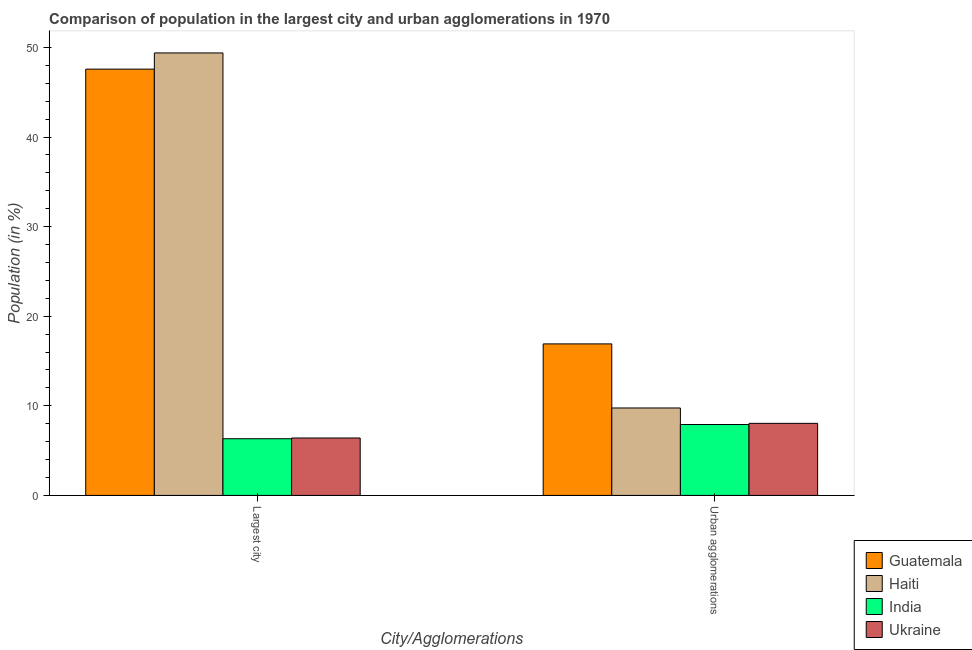Are the number of bars per tick equal to the number of legend labels?
Offer a terse response. Yes. Are the number of bars on each tick of the X-axis equal?
Your answer should be compact. Yes. What is the label of the 1st group of bars from the left?
Ensure brevity in your answer.  Largest city. What is the population in the largest city in Guatemala?
Make the answer very short. 47.58. Across all countries, what is the maximum population in the largest city?
Offer a terse response. 49.38. Across all countries, what is the minimum population in the largest city?
Offer a very short reply. 6.33. In which country was the population in urban agglomerations maximum?
Keep it short and to the point. Guatemala. In which country was the population in urban agglomerations minimum?
Your answer should be compact. India. What is the total population in urban agglomerations in the graph?
Offer a very short reply. 42.63. What is the difference between the population in the largest city in India and that in Haiti?
Your response must be concise. -43.06. What is the difference between the population in urban agglomerations in Guatemala and the population in the largest city in Haiti?
Offer a terse response. -32.47. What is the average population in urban agglomerations per country?
Provide a short and direct response. 10.66. What is the difference between the population in urban agglomerations and population in the largest city in India?
Your answer should be very brief. 1.59. In how many countries, is the population in urban agglomerations greater than 24 %?
Offer a very short reply. 0. What is the ratio of the population in urban agglomerations in India to that in Haiti?
Ensure brevity in your answer.  0.81. Is the population in the largest city in Haiti less than that in Ukraine?
Your answer should be very brief. No. In how many countries, is the population in the largest city greater than the average population in the largest city taken over all countries?
Keep it short and to the point. 2. How many bars are there?
Keep it short and to the point. 8. Are all the bars in the graph horizontal?
Keep it short and to the point. No. What is the difference between two consecutive major ticks on the Y-axis?
Provide a short and direct response. 10. Are the values on the major ticks of Y-axis written in scientific E-notation?
Your answer should be very brief. No. Does the graph contain any zero values?
Keep it short and to the point. No. Does the graph contain grids?
Your answer should be compact. No. Where does the legend appear in the graph?
Your response must be concise. Bottom right. How many legend labels are there?
Offer a terse response. 4. How are the legend labels stacked?
Provide a succinct answer. Vertical. What is the title of the graph?
Your answer should be very brief. Comparison of population in the largest city and urban agglomerations in 1970. What is the label or title of the X-axis?
Your answer should be compact. City/Agglomerations. What is the Population (in %) of Guatemala in Largest city?
Offer a very short reply. 47.58. What is the Population (in %) in Haiti in Largest city?
Offer a terse response. 49.38. What is the Population (in %) of India in Largest city?
Keep it short and to the point. 6.33. What is the Population (in %) of Ukraine in Largest city?
Offer a terse response. 6.41. What is the Population (in %) of Guatemala in Urban agglomerations?
Make the answer very short. 16.91. What is the Population (in %) in Haiti in Urban agglomerations?
Ensure brevity in your answer.  9.76. What is the Population (in %) of India in Urban agglomerations?
Provide a short and direct response. 7.91. What is the Population (in %) in Ukraine in Urban agglomerations?
Make the answer very short. 8.04. Across all City/Agglomerations, what is the maximum Population (in %) of Guatemala?
Your answer should be compact. 47.58. Across all City/Agglomerations, what is the maximum Population (in %) of Haiti?
Offer a very short reply. 49.38. Across all City/Agglomerations, what is the maximum Population (in %) in India?
Ensure brevity in your answer.  7.91. Across all City/Agglomerations, what is the maximum Population (in %) in Ukraine?
Your answer should be very brief. 8.04. Across all City/Agglomerations, what is the minimum Population (in %) in Guatemala?
Keep it short and to the point. 16.91. Across all City/Agglomerations, what is the minimum Population (in %) in Haiti?
Ensure brevity in your answer.  9.76. Across all City/Agglomerations, what is the minimum Population (in %) of India?
Ensure brevity in your answer.  6.33. Across all City/Agglomerations, what is the minimum Population (in %) of Ukraine?
Provide a short and direct response. 6.41. What is the total Population (in %) of Guatemala in the graph?
Make the answer very short. 64.49. What is the total Population (in %) in Haiti in the graph?
Your answer should be compact. 59.14. What is the total Population (in %) in India in the graph?
Offer a terse response. 14.24. What is the total Population (in %) in Ukraine in the graph?
Your response must be concise. 14.45. What is the difference between the Population (in %) in Guatemala in Largest city and that in Urban agglomerations?
Offer a terse response. 30.66. What is the difference between the Population (in %) of Haiti in Largest city and that in Urban agglomerations?
Your answer should be compact. 39.62. What is the difference between the Population (in %) in India in Largest city and that in Urban agglomerations?
Your answer should be compact. -1.59. What is the difference between the Population (in %) in Ukraine in Largest city and that in Urban agglomerations?
Ensure brevity in your answer.  -1.63. What is the difference between the Population (in %) in Guatemala in Largest city and the Population (in %) in Haiti in Urban agglomerations?
Provide a short and direct response. 37.82. What is the difference between the Population (in %) of Guatemala in Largest city and the Population (in %) of India in Urban agglomerations?
Keep it short and to the point. 39.66. What is the difference between the Population (in %) in Guatemala in Largest city and the Population (in %) in Ukraine in Urban agglomerations?
Your response must be concise. 39.53. What is the difference between the Population (in %) of Haiti in Largest city and the Population (in %) of India in Urban agglomerations?
Provide a short and direct response. 41.47. What is the difference between the Population (in %) in Haiti in Largest city and the Population (in %) in Ukraine in Urban agglomerations?
Offer a terse response. 41.34. What is the difference between the Population (in %) of India in Largest city and the Population (in %) of Ukraine in Urban agglomerations?
Keep it short and to the point. -1.72. What is the average Population (in %) in Guatemala per City/Agglomerations?
Give a very brief answer. 32.24. What is the average Population (in %) of Haiti per City/Agglomerations?
Keep it short and to the point. 29.57. What is the average Population (in %) of India per City/Agglomerations?
Your answer should be very brief. 7.12. What is the average Population (in %) of Ukraine per City/Agglomerations?
Provide a short and direct response. 7.23. What is the difference between the Population (in %) in Guatemala and Population (in %) in Haiti in Largest city?
Give a very brief answer. -1.81. What is the difference between the Population (in %) of Guatemala and Population (in %) of India in Largest city?
Your response must be concise. 41.25. What is the difference between the Population (in %) in Guatemala and Population (in %) in Ukraine in Largest city?
Keep it short and to the point. 41.17. What is the difference between the Population (in %) in Haiti and Population (in %) in India in Largest city?
Ensure brevity in your answer.  43.06. What is the difference between the Population (in %) in Haiti and Population (in %) in Ukraine in Largest city?
Your answer should be very brief. 42.97. What is the difference between the Population (in %) in India and Population (in %) in Ukraine in Largest city?
Your answer should be very brief. -0.08. What is the difference between the Population (in %) of Guatemala and Population (in %) of Haiti in Urban agglomerations?
Ensure brevity in your answer.  7.15. What is the difference between the Population (in %) of Guatemala and Population (in %) of India in Urban agglomerations?
Provide a succinct answer. 9. What is the difference between the Population (in %) in Guatemala and Population (in %) in Ukraine in Urban agglomerations?
Give a very brief answer. 8.87. What is the difference between the Population (in %) in Haiti and Population (in %) in India in Urban agglomerations?
Keep it short and to the point. 1.84. What is the difference between the Population (in %) of Haiti and Population (in %) of Ukraine in Urban agglomerations?
Your answer should be very brief. 1.72. What is the difference between the Population (in %) in India and Population (in %) in Ukraine in Urban agglomerations?
Your answer should be very brief. -0.13. What is the ratio of the Population (in %) of Guatemala in Largest city to that in Urban agglomerations?
Offer a terse response. 2.81. What is the ratio of the Population (in %) in Haiti in Largest city to that in Urban agglomerations?
Ensure brevity in your answer.  5.06. What is the ratio of the Population (in %) of India in Largest city to that in Urban agglomerations?
Offer a terse response. 0.8. What is the ratio of the Population (in %) of Ukraine in Largest city to that in Urban agglomerations?
Keep it short and to the point. 0.8. What is the difference between the highest and the second highest Population (in %) of Guatemala?
Give a very brief answer. 30.66. What is the difference between the highest and the second highest Population (in %) of Haiti?
Give a very brief answer. 39.62. What is the difference between the highest and the second highest Population (in %) of India?
Provide a short and direct response. 1.59. What is the difference between the highest and the second highest Population (in %) of Ukraine?
Make the answer very short. 1.63. What is the difference between the highest and the lowest Population (in %) of Guatemala?
Offer a very short reply. 30.66. What is the difference between the highest and the lowest Population (in %) in Haiti?
Give a very brief answer. 39.62. What is the difference between the highest and the lowest Population (in %) of India?
Provide a short and direct response. 1.59. What is the difference between the highest and the lowest Population (in %) of Ukraine?
Ensure brevity in your answer.  1.63. 